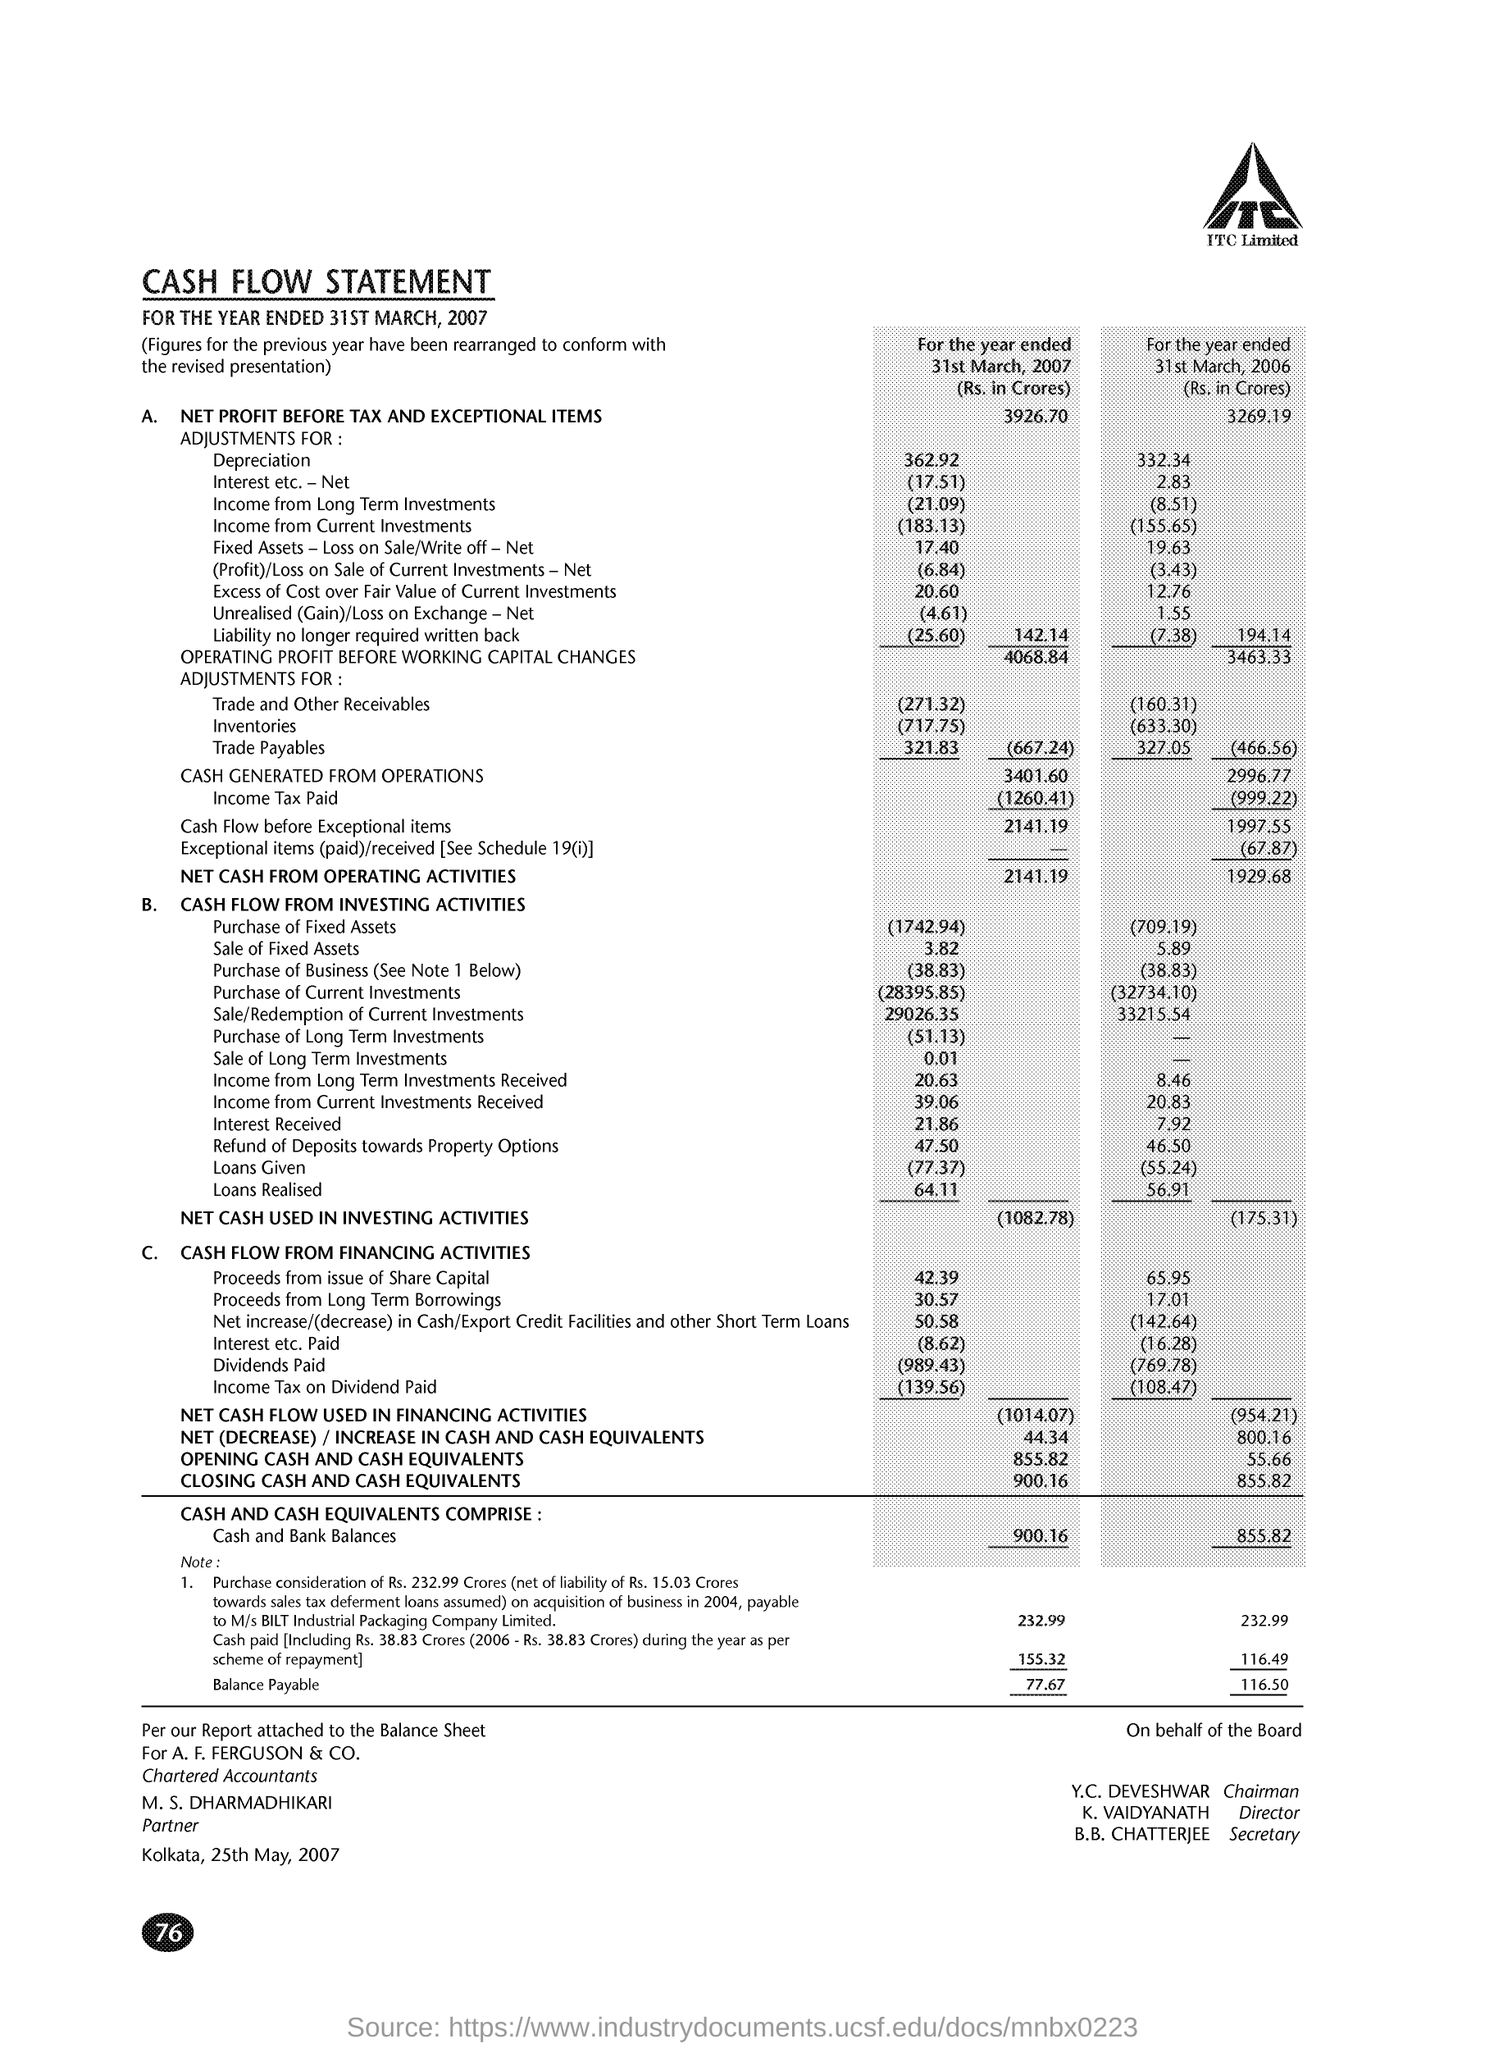Point out several critical features in this image. The income tax paid for the year ended 31st March, 2006 was Rs. 999.22 crores. During the year ended March 31, 2007, the cash generated from operations was approximately 3,401.60 crores. The net cash from operating activities for the year ended 31st March 2007 was 2141.19 crore rupees. The opening cash and cash equivalents for the year ended March 31, 2007 was Rs. 855.82 crore. The net profit before tax and exceptional items for the year ended March 31, 2007 was Rs. 3,926.70 crores. 